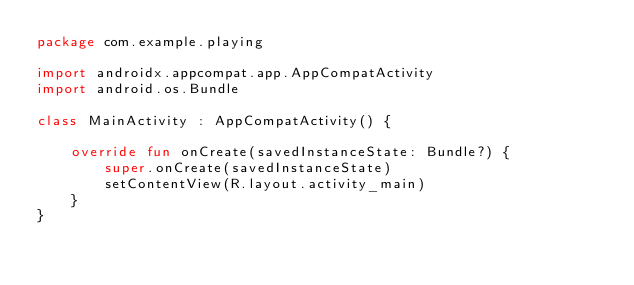<code> <loc_0><loc_0><loc_500><loc_500><_Kotlin_>package com.example.playing

import androidx.appcompat.app.AppCompatActivity
import android.os.Bundle

class MainActivity : AppCompatActivity() {

    override fun onCreate(savedInstanceState: Bundle?) {
        super.onCreate(savedInstanceState)
        setContentView(R.layout.activity_main)
    }
}
</code> 